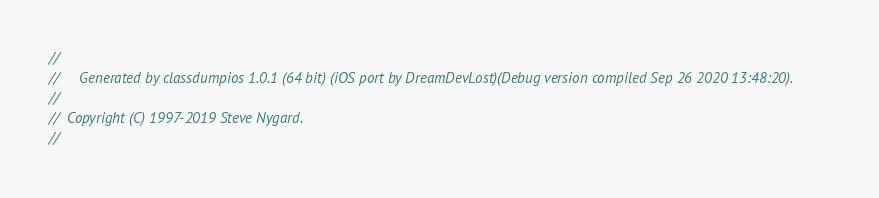Convert code to text. <code><loc_0><loc_0><loc_500><loc_500><_C_>//
//     Generated by classdumpios 1.0.1 (64 bit) (iOS port by DreamDevLost)(Debug version compiled Sep 26 2020 13:48:20).
//
//  Copyright (C) 1997-2019 Steve Nygard.
//
</code> 